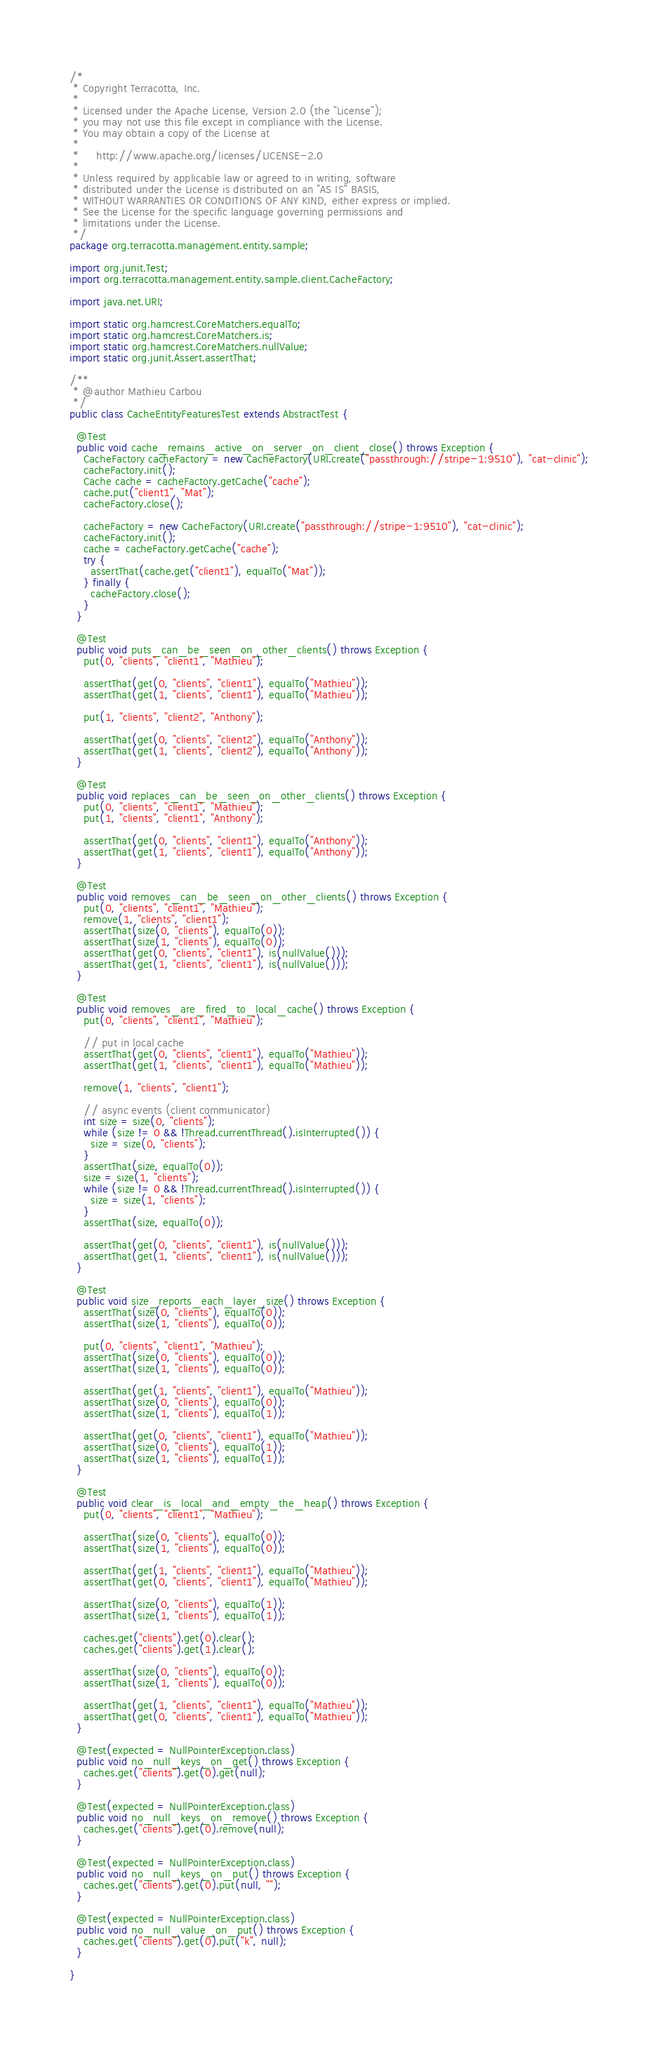Convert code to text. <code><loc_0><loc_0><loc_500><loc_500><_Java_>/*
 * Copyright Terracotta, Inc.
 *
 * Licensed under the Apache License, Version 2.0 (the "License");
 * you may not use this file except in compliance with the License.
 * You may obtain a copy of the License at
 *
 *     http://www.apache.org/licenses/LICENSE-2.0
 *
 * Unless required by applicable law or agreed to in writing, software
 * distributed under the License is distributed on an "AS IS" BASIS,
 * WITHOUT WARRANTIES OR CONDITIONS OF ANY KIND, either express or implied.
 * See the License for the specific language governing permissions and
 * limitations under the License.
 */
package org.terracotta.management.entity.sample;

import org.junit.Test;
import org.terracotta.management.entity.sample.client.CacheFactory;

import java.net.URI;

import static org.hamcrest.CoreMatchers.equalTo;
import static org.hamcrest.CoreMatchers.is;
import static org.hamcrest.CoreMatchers.nullValue;
import static org.junit.Assert.assertThat;

/**
 * @author Mathieu Carbou
 */
public class CacheEntityFeaturesTest extends AbstractTest {

  @Test
  public void cache_remains_active_on_server_on_client_close() throws Exception {
    CacheFactory cacheFactory = new CacheFactory(URI.create("passthrough://stripe-1:9510"), "cat-clinic");
    cacheFactory.init();
    Cache cache = cacheFactory.getCache("cache");
    cache.put("client1", "Mat");
    cacheFactory.close();

    cacheFactory = new CacheFactory(URI.create("passthrough://stripe-1:9510"), "cat-clinic");
    cacheFactory.init();
    cache = cacheFactory.getCache("cache");
    try {
      assertThat(cache.get("client1"), equalTo("Mat"));
    } finally {
      cacheFactory.close();
    }
  }

  @Test
  public void puts_can_be_seen_on_other_clients() throws Exception {
    put(0, "clients", "client1", "Mathieu");

    assertThat(get(0, "clients", "client1"), equalTo("Mathieu"));
    assertThat(get(1, "clients", "client1"), equalTo("Mathieu"));

    put(1, "clients", "client2", "Anthony");

    assertThat(get(0, "clients", "client2"), equalTo("Anthony"));
    assertThat(get(1, "clients", "client2"), equalTo("Anthony"));
  }

  @Test
  public void replaces_can_be_seen_on_other_clients() throws Exception {
    put(0, "clients", "client1", "Mathieu");
    put(1, "clients", "client1", "Anthony");

    assertThat(get(0, "clients", "client1"), equalTo("Anthony"));
    assertThat(get(1, "clients", "client1"), equalTo("Anthony"));
  }

  @Test
  public void removes_can_be_seen_on_other_clients() throws Exception {
    put(0, "clients", "client1", "Mathieu");
    remove(1, "clients", "client1");
    assertThat(size(0, "clients"), equalTo(0));
    assertThat(size(1, "clients"), equalTo(0));
    assertThat(get(0, "clients", "client1"), is(nullValue()));
    assertThat(get(1, "clients", "client1"), is(nullValue()));
  }

  @Test
  public void removes_are_fired_to_local_cache() throws Exception {
    put(0, "clients", "client1", "Mathieu");

    // put in local cache
    assertThat(get(0, "clients", "client1"), equalTo("Mathieu"));
    assertThat(get(1, "clients", "client1"), equalTo("Mathieu"));

    remove(1, "clients", "client1");

    // async events (client communicator)
    int size = size(0, "clients");
    while (size != 0 && !Thread.currentThread().isInterrupted()) {
      size = size(0, "clients");
    }
    assertThat(size, equalTo(0));
    size = size(1, "clients");
    while (size != 0 && !Thread.currentThread().isInterrupted()) {
      size = size(1, "clients");
    }
    assertThat(size, equalTo(0));

    assertThat(get(0, "clients", "client1"), is(nullValue()));
    assertThat(get(1, "clients", "client1"), is(nullValue()));
  }

  @Test
  public void size_reports_each_layer_size() throws Exception {
    assertThat(size(0, "clients"), equalTo(0));
    assertThat(size(1, "clients"), equalTo(0));

    put(0, "clients", "client1", "Mathieu");
    assertThat(size(0, "clients"), equalTo(0));
    assertThat(size(1, "clients"), equalTo(0));

    assertThat(get(1, "clients", "client1"), equalTo("Mathieu"));
    assertThat(size(0, "clients"), equalTo(0));
    assertThat(size(1, "clients"), equalTo(1));

    assertThat(get(0, "clients", "client1"), equalTo("Mathieu"));
    assertThat(size(0, "clients"), equalTo(1));
    assertThat(size(1, "clients"), equalTo(1));
  }

  @Test
  public void clear_is_local_and_empty_the_heap() throws Exception {
    put(0, "clients", "client1", "Mathieu");

    assertThat(size(0, "clients"), equalTo(0));
    assertThat(size(1, "clients"), equalTo(0));

    assertThat(get(1, "clients", "client1"), equalTo("Mathieu"));
    assertThat(get(0, "clients", "client1"), equalTo("Mathieu"));

    assertThat(size(0, "clients"), equalTo(1));
    assertThat(size(1, "clients"), equalTo(1));

    caches.get("clients").get(0).clear();
    caches.get("clients").get(1).clear();

    assertThat(size(0, "clients"), equalTo(0));
    assertThat(size(1, "clients"), equalTo(0));

    assertThat(get(1, "clients", "client1"), equalTo("Mathieu"));
    assertThat(get(0, "clients", "client1"), equalTo("Mathieu"));
  }

  @Test(expected = NullPointerException.class)
  public void no_null_keys_on_get() throws Exception {
    caches.get("clients").get(0).get(null);
  }

  @Test(expected = NullPointerException.class)
  public void no_null_keys_on_remove() throws Exception {
    caches.get("clients").get(0).remove(null);
  }

  @Test(expected = NullPointerException.class)
  public void no_null_keys_on_put() throws Exception {
    caches.get("clients").get(0).put(null, "");
  }

  @Test(expected = NullPointerException.class)
  public void no_null_value_on_put() throws Exception {
    caches.get("clients").get(0).put("k", null);
  }

}
</code> 